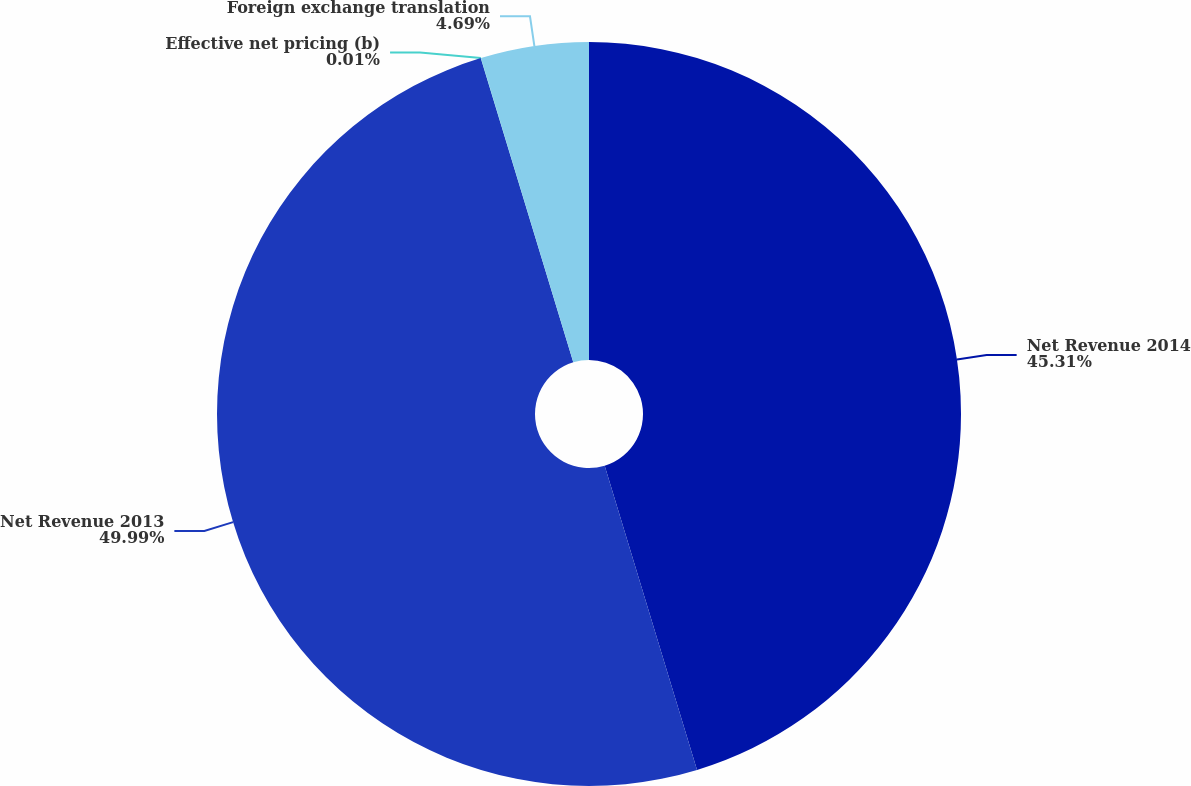Convert chart to OTSL. <chart><loc_0><loc_0><loc_500><loc_500><pie_chart><fcel>Net Revenue 2014<fcel>Net Revenue 2013<fcel>Effective net pricing (b)<fcel>Foreign exchange translation<nl><fcel>45.31%<fcel>49.99%<fcel>0.01%<fcel>4.69%<nl></chart> 